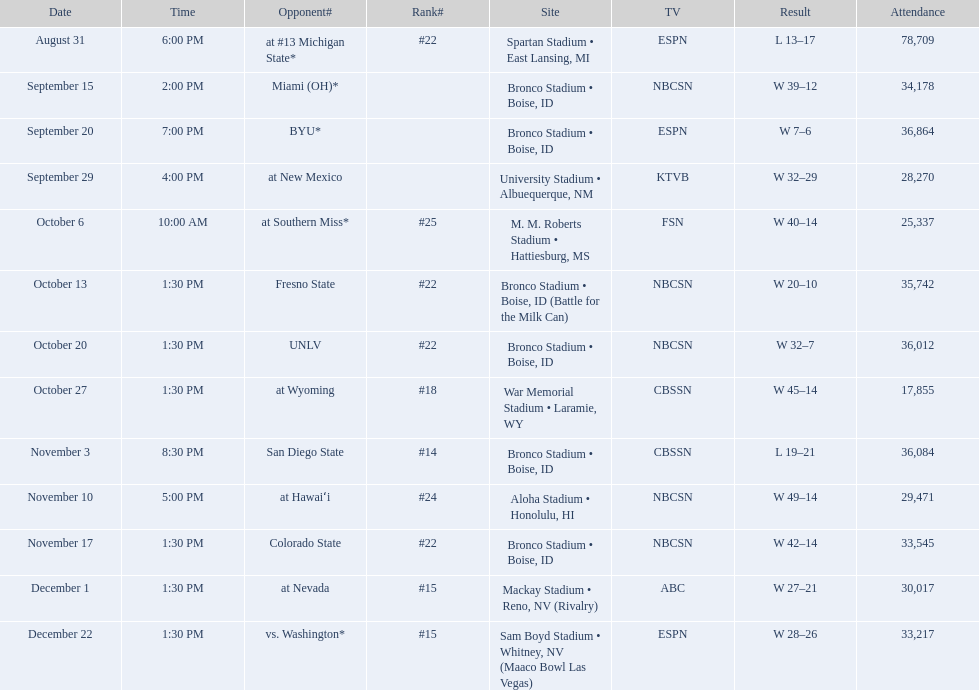What were the team's recorded standings for the season? #22, , , , #25, #22, #22, #18, #14, #24, #22, #15, #15. Which of these positions is the best? #14. Who were all the adversaries? At #13 michigan state*, miami (oh)*, byu*, at new mexico, at southern miss*, fresno state, unlv, at wyoming, san diego state, at hawaiʻi, colorado state, at nevada, vs. washington*. Who were their opponents on november 3rd? San Diego State. What position did they hold on november 3rd? #14. 